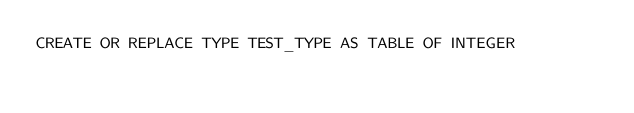<code> <loc_0><loc_0><loc_500><loc_500><_SQL_>CREATE OR REPLACE TYPE TEST_TYPE AS TABLE OF INTEGER</code> 